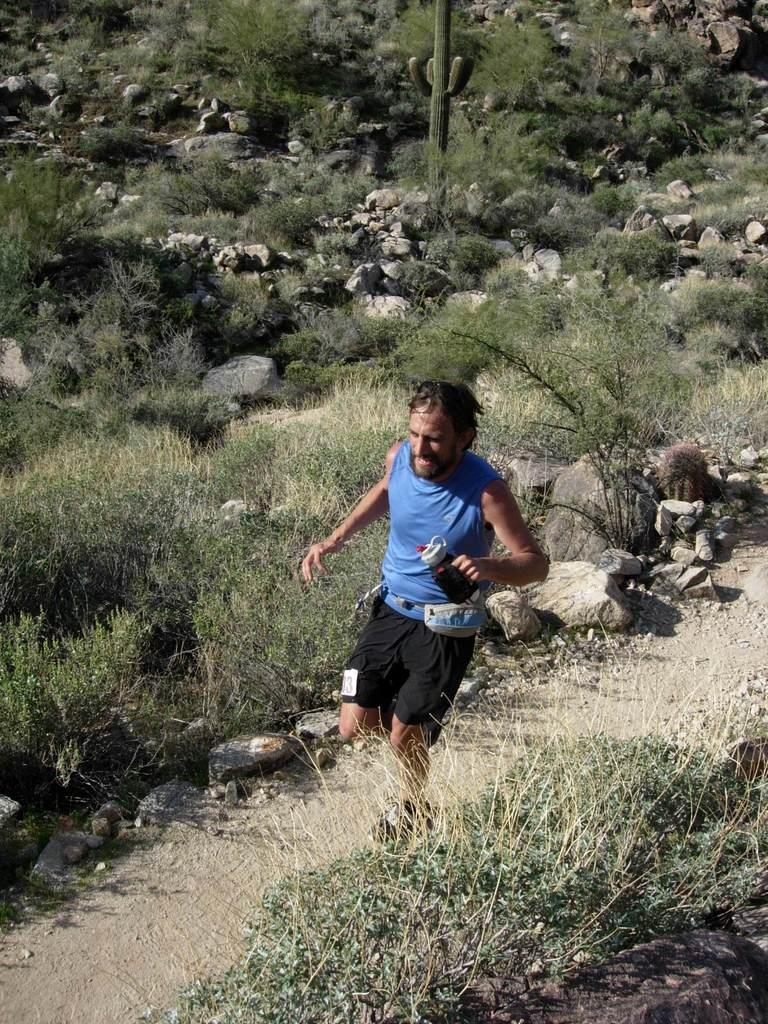Can you describe this image briefly? This image is taken outdoors. At the bottom of the image there is a ground with grass on it and there are a few plants on the ground. In the background there are many plants with leaves and stems. There are many rocks and stones on the ground. There is a pole. In the middle of the image a man is running on the ground and he is holding a bottle in his hand. 